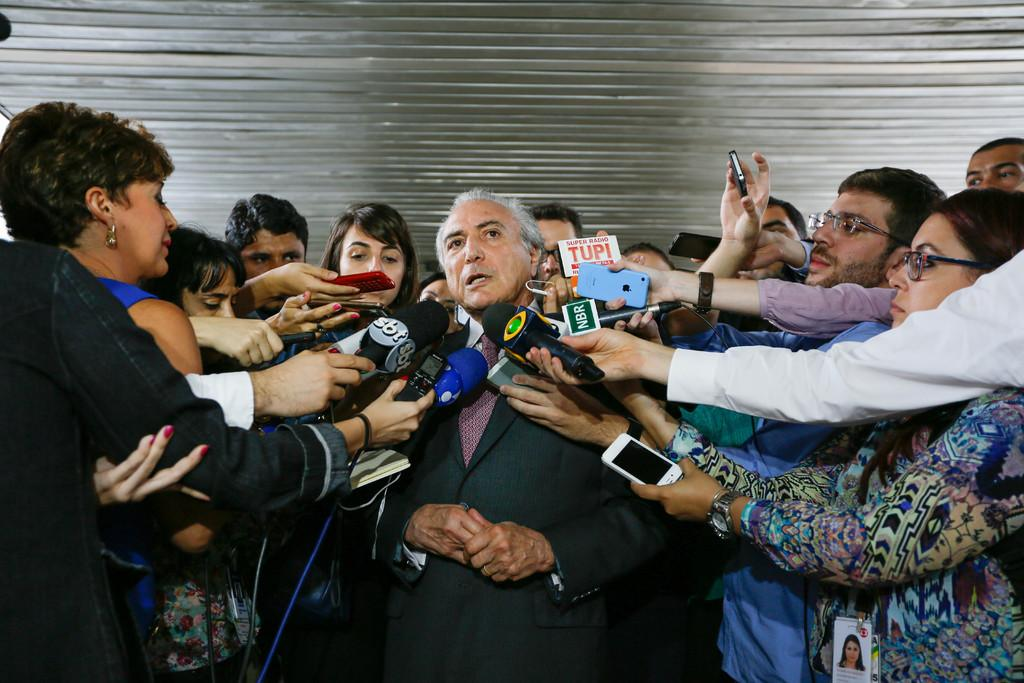What is happening in the image? There is a person being interviewed in the image. How many journalists are present in the image? There are multiple journalists present in the image. What equipment is being used to record the interview? There are plenty of microphones and mobile recorders visible in the image. What type of jewel is the person being interviewed wearing in the image? There is no mention of any jewelry in the image, so it cannot be determined if the person is wearing a jewel. 